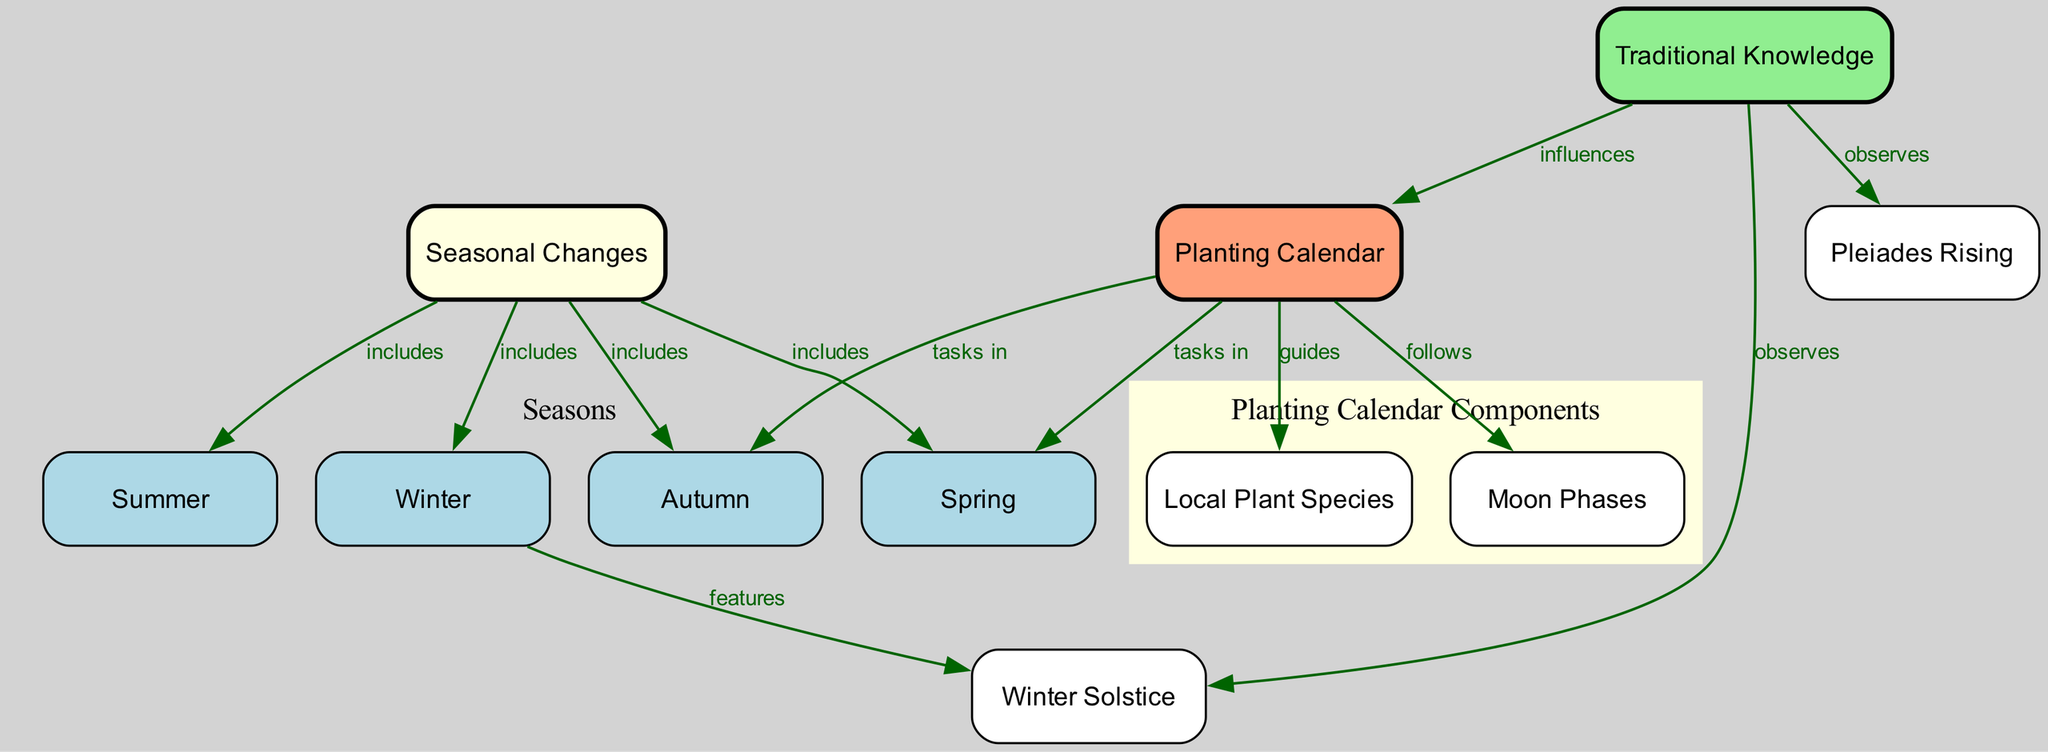What is the main concept represented at the top of the diagram? The node at the top of the diagram represents "Seasonal Changes," which is the central theme of the diagram, showing the overall concept that encompasses the various seasons and their relation to planting activities.
Answer: Seasonal Changes How many seasons are included in the diagram? The diagram includes four seasons: Winter, Spring, Summer, and Autumn, all of which are directly connected to the main concept of Seasonal Changes.
Answer: Four Which season is associated with the Winter Solstice? According to the diagram, Winter is the season that features the Winter Solstice, as indicated by the labeled edge connecting these two nodes.
Answer: Winter What guides the Planting Calendar based on traditional knowledge? The Traditional Knowledge directs the Planting Calendar, as shown by the edge indicating that Traditional Knowledge influences the Planting Calendar directly.
Answer: Traditional Knowledge In which season are planting tasks associated? The diagram shows that planting tasks are associated with both Spring and Autumn, connecting these seasons to the activities in the Planting Calendar.
Answer: Spring and Autumn How do Moon Phases relate to the Planting Calendar? The diagram indicates that the Planting Calendar follows the Moon Phases, connecting lunar cycles to agricultural practices and planting activities highlighted in the calendar.
Answer: Follows What celestial event signifies a change in the seasonal cycle? The Pleiades Rising is highlighted in the diagram as a celestial event that signifies change and serves as a planting guide, observed by indigenous knowledge.
Answer: Pleiades Rising Which color represents the Seasonal Changes node in the diagram? The Seasonal Changes node is highlighted in light yellow, denoting its importance as the central theme of the diagram.
Answer: Light yellow What type of knowledge influences the planting calendar tasks? The diagram indicates that Traditional Knowledge influences tasks related to the Planting Calendar, emphasizing the role of indigenous understanding in agricultural cycles.
Answer: Traditional Knowledge What do the edges in the diagram represent? The edges in the diagram represent the relationships and connections between nodes, such as inclusion, influence, and guidance regarding seasonal changes and planting activities.
Answer: Relationships and connections 